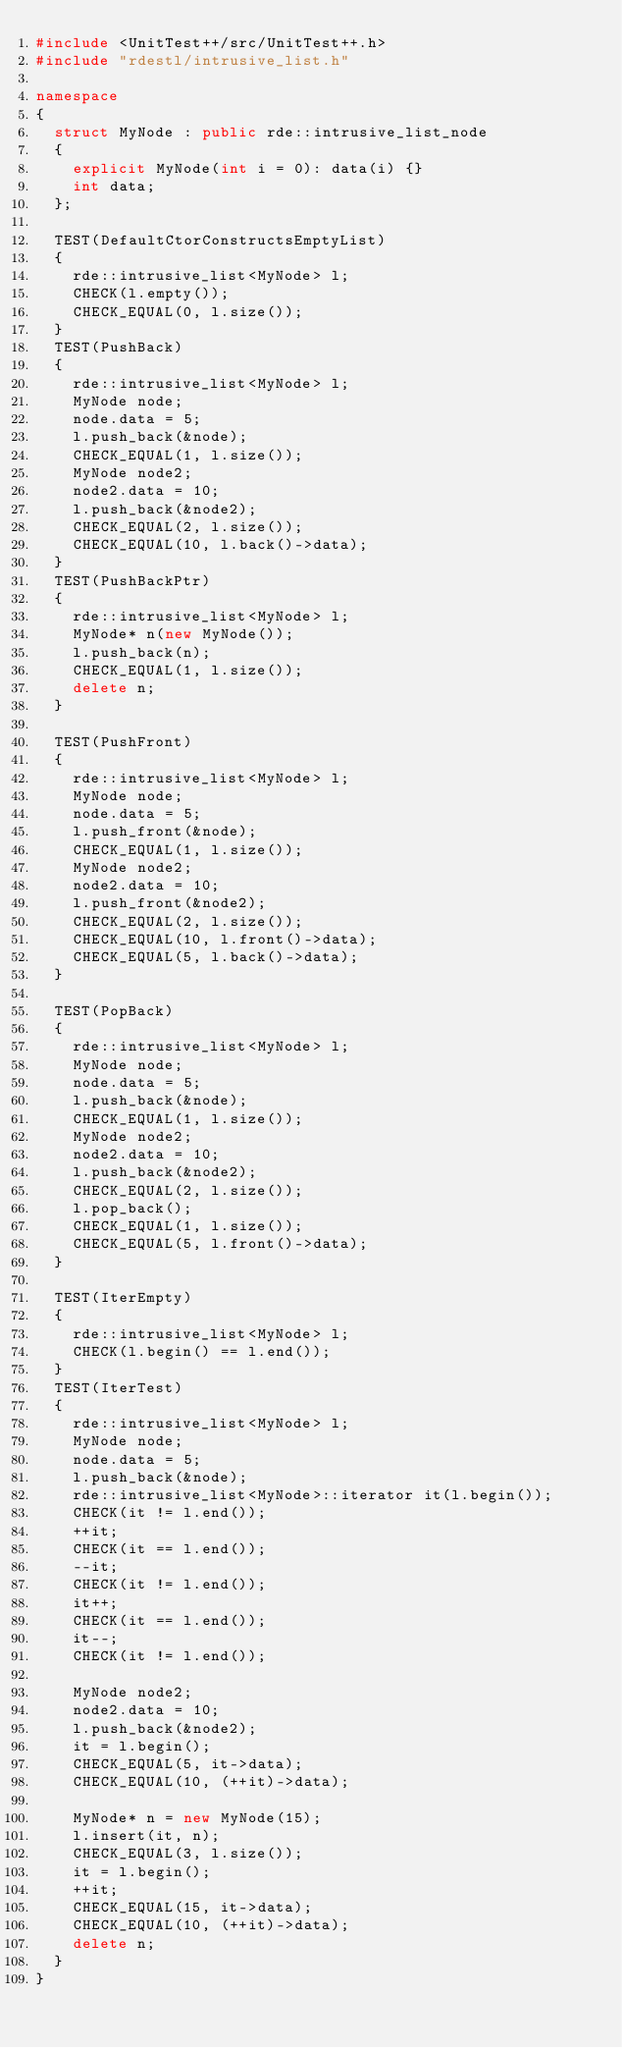Convert code to text. <code><loc_0><loc_0><loc_500><loc_500><_C++_>#include <UnitTest++/src/UnitTest++.h>
#include "rdestl/intrusive_list.h"

namespace
{
	struct MyNode : public rde::intrusive_list_node
	{
		explicit MyNode(int i = 0): data(i) {}
		int	data;
	};

	TEST(DefaultCtorConstructsEmptyList)
	{
		rde::intrusive_list<MyNode> l;
		CHECK(l.empty());
		CHECK_EQUAL(0, l.size());
	}
	TEST(PushBack)
	{
		rde::intrusive_list<MyNode> l;
		MyNode node;
		node.data = 5;
		l.push_back(&node);
		CHECK_EQUAL(1, l.size());
		MyNode node2;
		node2.data = 10;
		l.push_back(&node2);
		CHECK_EQUAL(2, l.size());
		CHECK_EQUAL(10, l.back()->data);
	}
	TEST(PushBackPtr)
	{
		rde::intrusive_list<MyNode> l;
		MyNode* n(new MyNode());
		l.push_back(n);
		CHECK_EQUAL(1, l.size());
		delete n;
	}

	TEST(PushFront)
	{
		rde::intrusive_list<MyNode> l;
		MyNode node;
		node.data = 5;
		l.push_front(&node);
		CHECK_EQUAL(1, l.size());
		MyNode node2;
		node2.data = 10;
		l.push_front(&node2);
		CHECK_EQUAL(2, l.size());
		CHECK_EQUAL(10, l.front()->data);
		CHECK_EQUAL(5, l.back()->data);
	}

	TEST(PopBack)
	{
		rde::intrusive_list<MyNode> l;
		MyNode node;
		node.data = 5;
		l.push_back(&node);
		CHECK_EQUAL(1, l.size());
		MyNode node2;
		node2.data = 10;
		l.push_back(&node2);
		CHECK_EQUAL(2, l.size());
		l.pop_back();
		CHECK_EQUAL(1, l.size());
		CHECK_EQUAL(5, l.front()->data);
	}

	TEST(IterEmpty)
	{
		rde::intrusive_list<MyNode> l;
		CHECK(l.begin() == l.end());
	}
	TEST(IterTest)
	{
		rde::intrusive_list<MyNode> l;
		MyNode node;
		node.data = 5;
		l.push_back(&node);
		rde::intrusive_list<MyNode>::iterator it(l.begin());
		CHECK(it != l.end());
		++it;
		CHECK(it == l.end());
		--it;
		CHECK(it != l.end());
		it++;
		CHECK(it == l.end());
		it--;
		CHECK(it != l.end());

		MyNode node2;
		node2.data = 10;
		l.push_back(&node2);
		it = l.begin();
		CHECK_EQUAL(5, it->data);
		CHECK_EQUAL(10, (++it)->data);

		MyNode* n = new MyNode(15);
		l.insert(it, n);
		CHECK_EQUAL(3, l.size());
		it = l.begin();
		++it;
		CHECK_EQUAL(15, it->data);
		CHECK_EQUAL(10, (++it)->data);
		delete n;
	}
}

</code> 